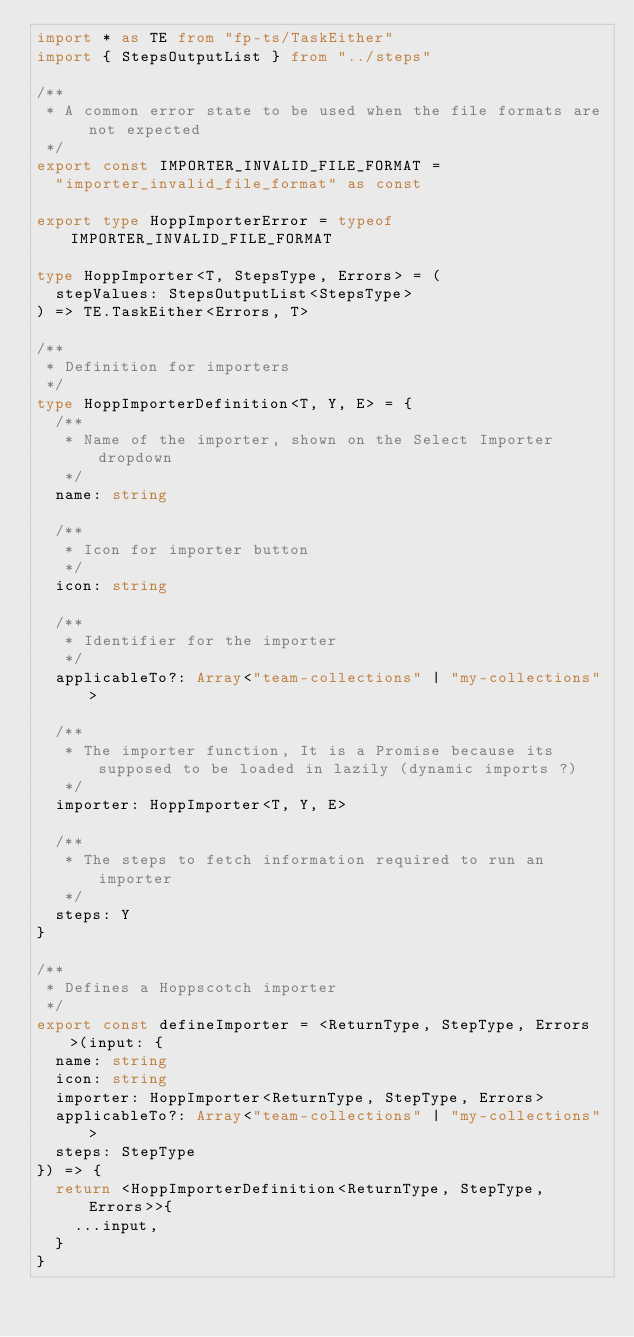Convert code to text. <code><loc_0><loc_0><loc_500><loc_500><_TypeScript_>import * as TE from "fp-ts/TaskEither"
import { StepsOutputList } from "../steps"

/**
 * A common error state to be used when the file formats are not expected
 */
export const IMPORTER_INVALID_FILE_FORMAT =
  "importer_invalid_file_format" as const

export type HoppImporterError = typeof IMPORTER_INVALID_FILE_FORMAT

type HoppImporter<T, StepsType, Errors> = (
  stepValues: StepsOutputList<StepsType>
) => TE.TaskEither<Errors, T>

/**
 * Definition for importers
 */
type HoppImporterDefinition<T, Y, E> = {
  /**
   * Name of the importer, shown on the Select Importer dropdown
   */
  name: string

  /**
   * Icon for importer button
   */
  icon: string

  /**
   * Identifier for the importer
   */
  applicableTo?: Array<"team-collections" | "my-collections">

  /**
   * The importer function, It is a Promise because its supposed to be loaded in lazily (dynamic imports ?)
   */
  importer: HoppImporter<T, Y, E>

  /**
   * The steps to fetch information required to run an importer
   */
  steps: Y
}

/**
 * Defines a Hoppscotch importer
 */
export const defineImporter = <ReturnType, StepType, Errors>(input: {
  name: string
  icon: string
  importer: HoppImporter<ReturnType, StepType, Errors>
  applicableTo?: Array<"team-collections" | "my-collections">
  steps: StepType
}) => {
  return <HoppImporterDefinition<ReturnType, StepType, Errors>>{
    ...input,
  }
}
</code> 